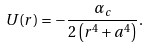Convert formula to latex. <formula><loc_0><loc_0><loc_500><loc_500>U ( r ) = - \frac { \alpha _ { c } } { 2 \left ( r ^ { 4 } + a ^ { 4 } \right ) } .</formula> 